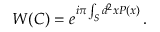Convert formula to latex. <formula><loc_0><loc_0><loc_500><loc_500>W ( C ) = e ^ { i \pi \int _ { S } d ^ { 2 } x P ( x ) } \, .</formula> 